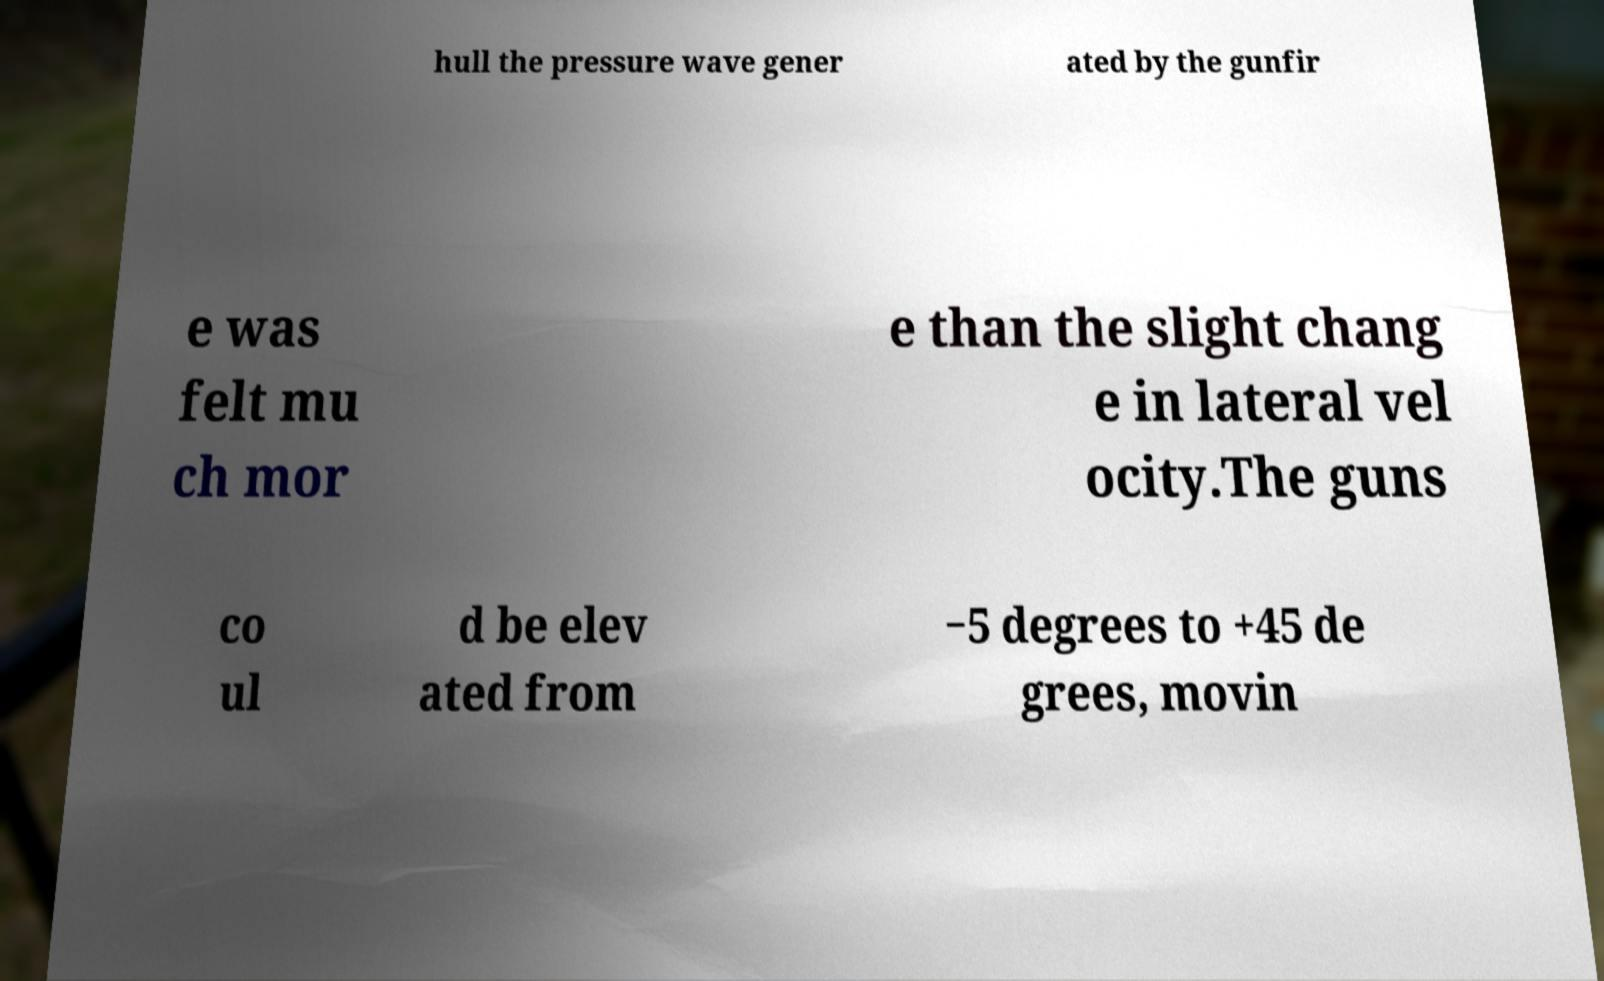There's text embedded in this image that I need extracted. Can you transcribe it verbatim? hull the pressure wave gener ated by the gunfir e was felt mu ch mor e than the slight chang e in lateral vel ocity.The guns co ul d be elev ated from −5 degrees to +45 de grees, movin 